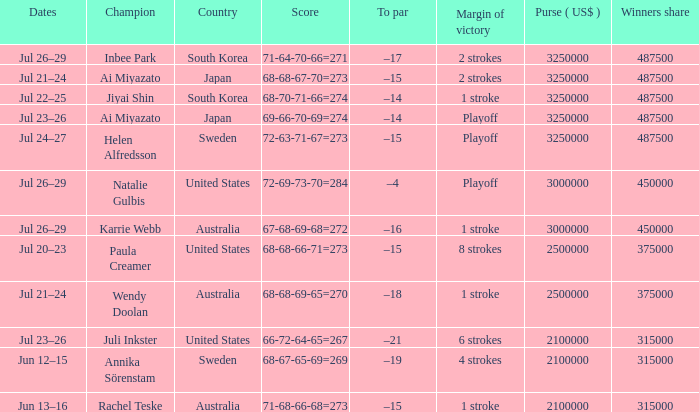What is the lowest year listed? 2001.0. 